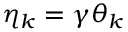<formula> <loc_0><loc_0><loc_500><loc_500>\eta _ { k } = \gamma \theta _ { k }</formula> 